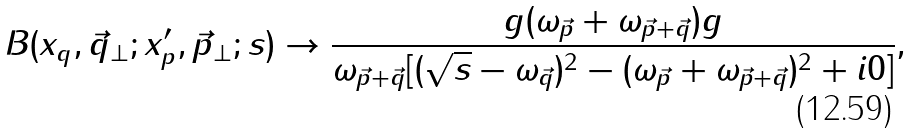Convert formula to latex. <formula><loc_0><loc_0><loc_500><loc_500>B ( x _ { q } , \vec { q } _ { \perp } ; x ^ { \prime } _ { p } , \vec { p } _ { \perp } ; s ) \to \frac { g ( \omega _ { \vec { p } } + \omega _ { \vec { p } + \vec { q } } ) g } { \omega _ { \vec { p } + \vec { q } } [ ( \sqrt { s } - \omega _ { \vec { q } } ) ^ { 2 } - ( \omega _ { \vec { p } } + \omega _ { \vec { p } + \vec { q } } ) ^ { 2 } + i 0 ] } ,</formula> 